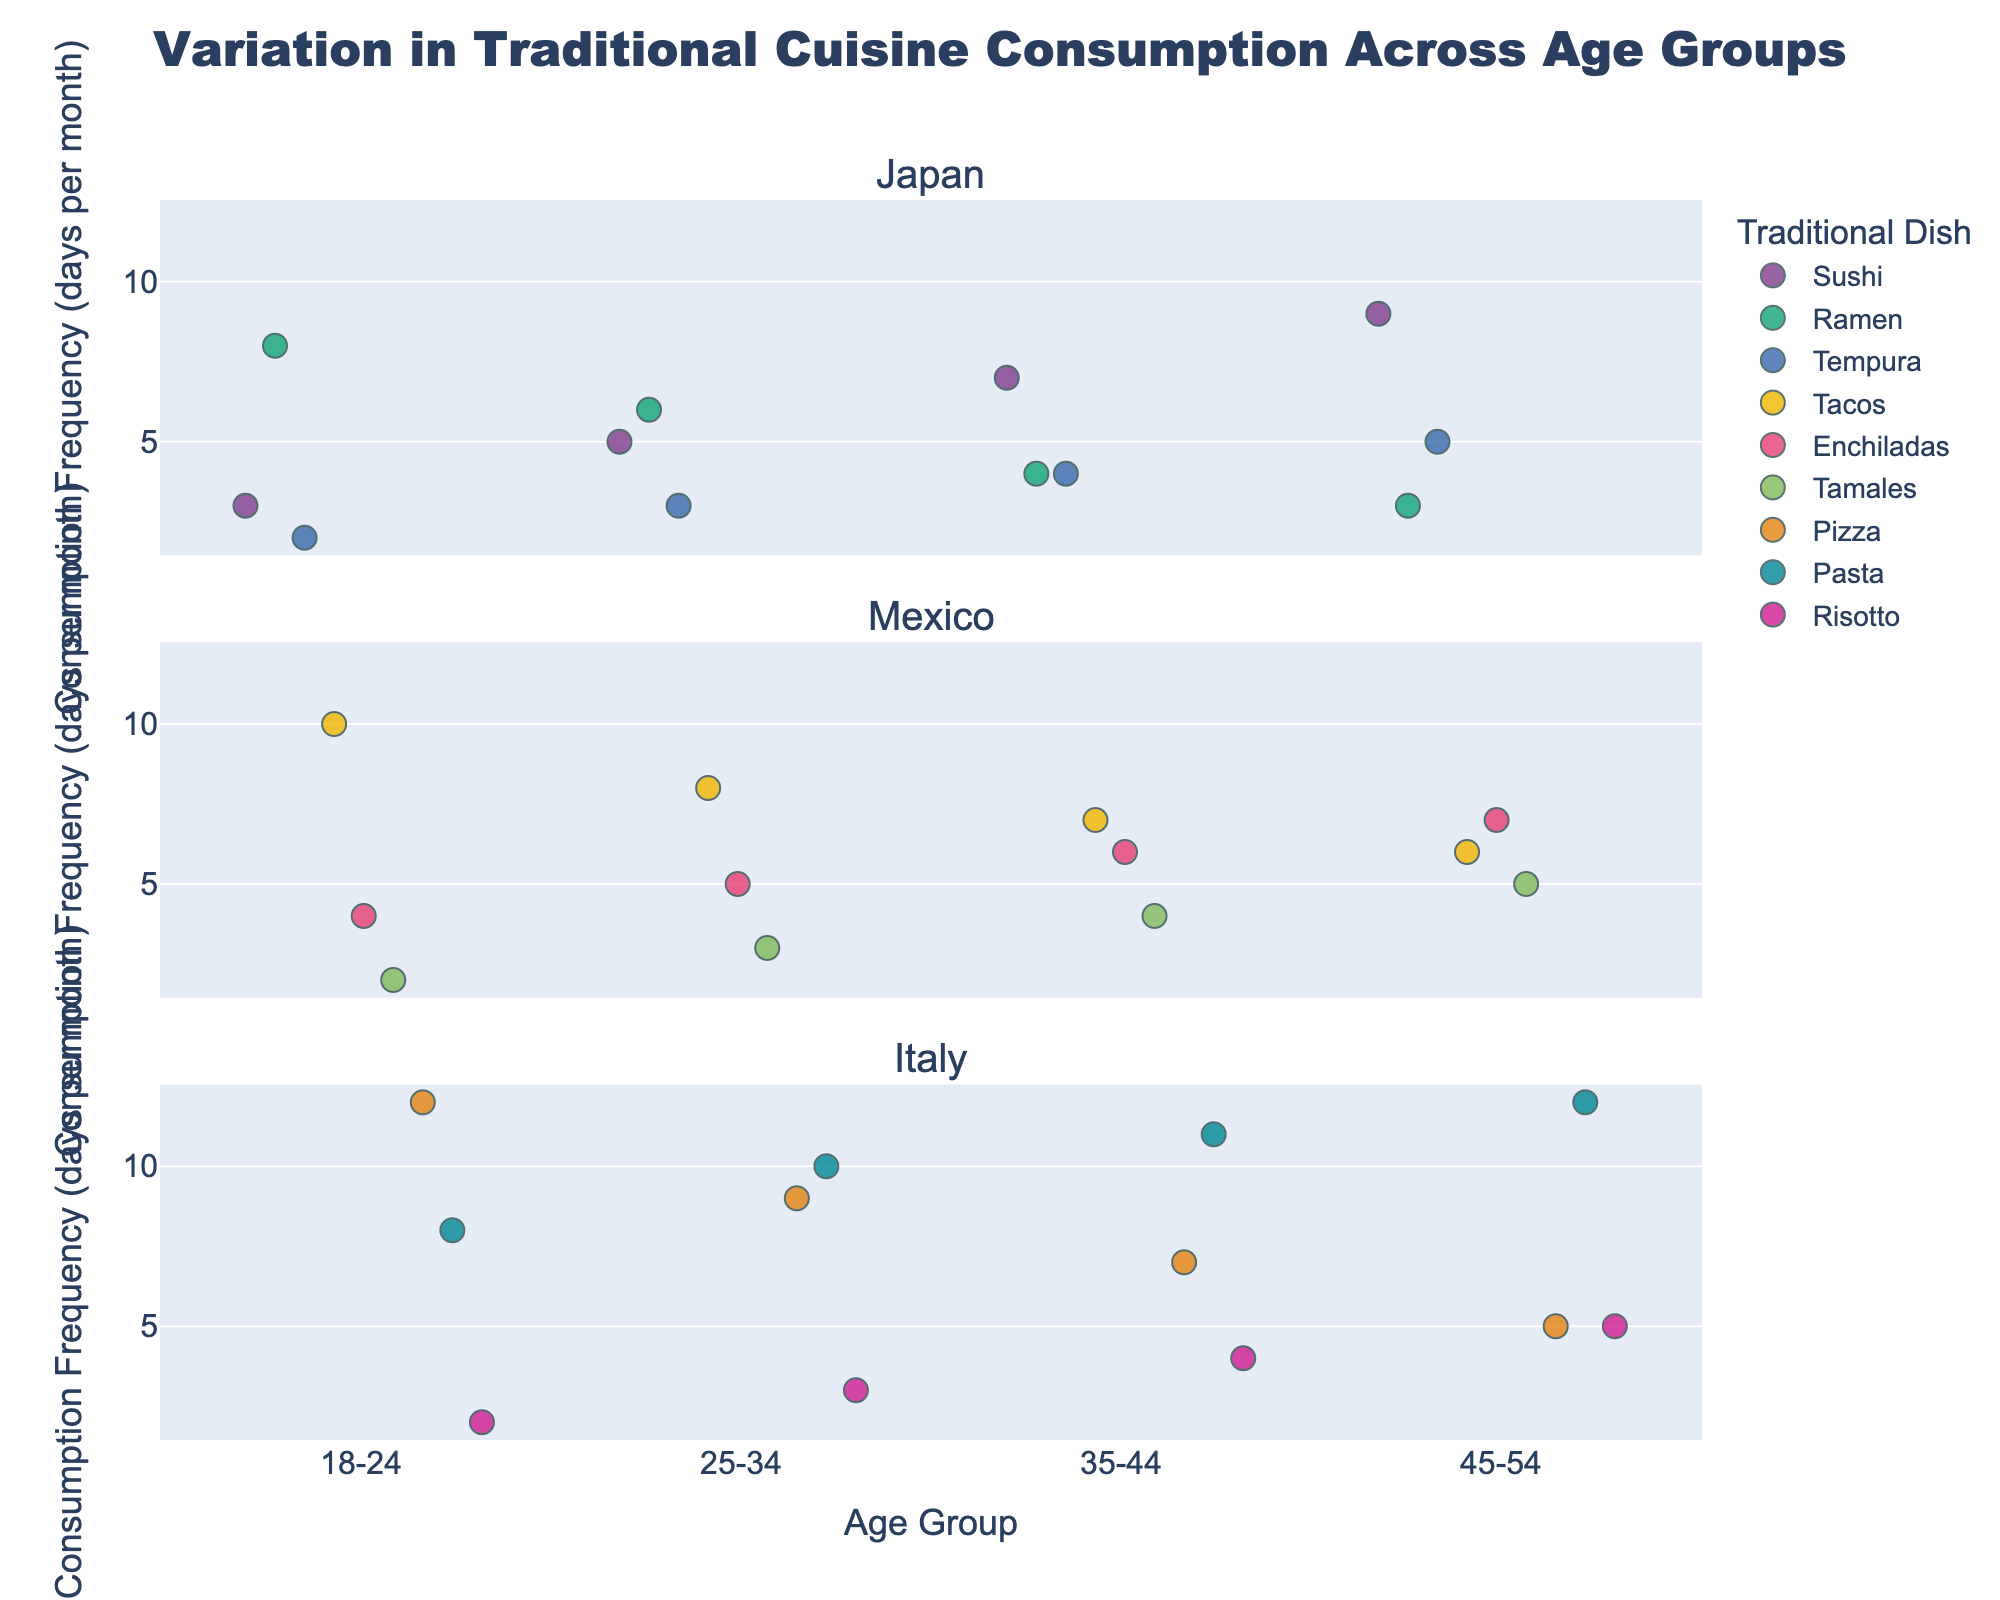What is the title of the plot? The title is centered at the top, displayed in a large font.
Answer: Variation in Traditional Cuisine Consumption Across Age Groups What is the age group with the highest consumption frequency for Sushi in Japan? Look for Sushi data points under the Japan facet. The 45-54 age group has the highest value at 9 days per month.
Answer: 45-54 How does the consumption of Pizza in Italy change across age groups? Examine all Pizza data points in the Italy facet. Consumption frequency decreases as age increases: 12 for 18-24, 9 for 25-34, 7 for 35-44, and 5 for 45-54.
Answer: Decreases Which traditional dish in Mexico is consumed most frequently by the 18-24 age group? Check the data points under the Mexico facet for the 18-24 age group. Tacos has the highest frequency at 10 days per month.
Answer: Tacos Compare the average consumption frequency of Tamales in Mexico between the 25-34 and 45-54 age groups. Average the frequencies for each age group: (3 for 25-34 and 5 for 45-54). (3 + 5)/2 gives 4.
Answer: 4 What traditional dish in Japan shows the smallest variation in consumption frequency across all age groups? Examine the range of frequencies for each dish. Ramen shows the smallest variation, ranging from 3 to 8 days per month.
Answer: Ramen Which age group in Italy has the highest average consumption frequency of traditional dishes? Calculate the average for each age group: (12+8+2)/3 for 18-24, (9+10+3)/3 for 25-34, (7+11+4)/3 for 35-44, and (5+12+5)/3 for 45-54. 45-54 has the highest average at 7.33.
Answer: 45-54 What is the difference in Sushi consumption between the 18-24 and 45-54 age groups in Japan? Subtract the frequency for the 18-24 age group (3) from the frequency for the 45-54 age group (9). 9 - 3 = 6.
Answer: 6 